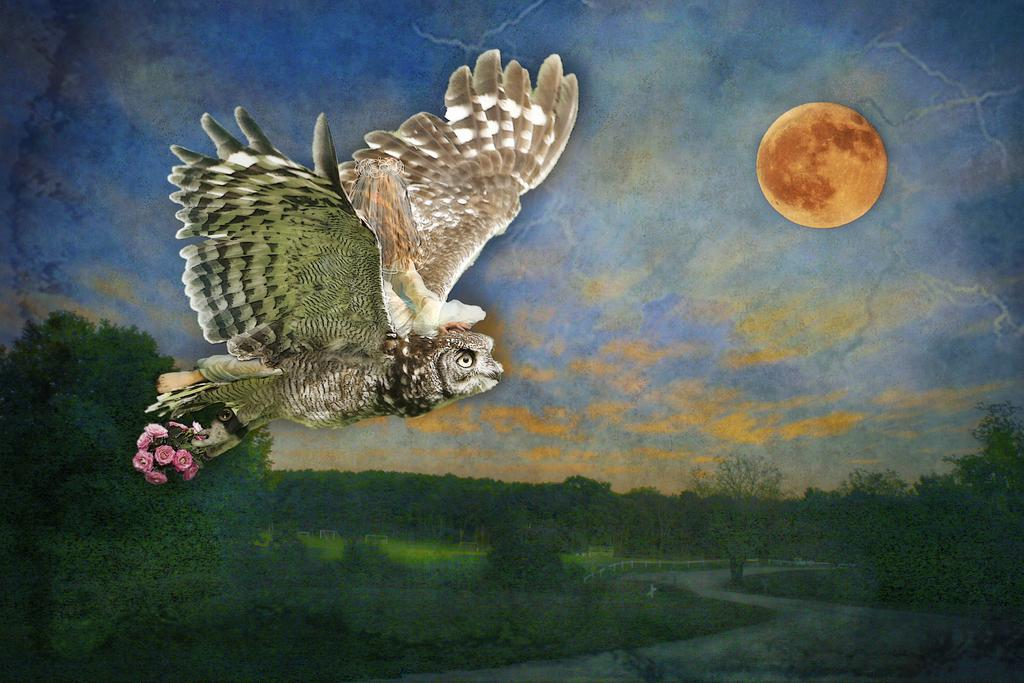What animal is present in the image? There is an owl in the image. Where is the owl located in the image? The owl is on the left side of the image. What is the owl holding in its claws? The owl is holding flowers in its claws. What type of vegetation can be seen at the bottom of the image? There is greenery at the bottom of the image. What celestial body is visible in the image? There is a moon visible in the image. What type of insurance policy does the owl have for its flowers? There is no information about insurance policies in the image, as it features an owl holding flowers. 